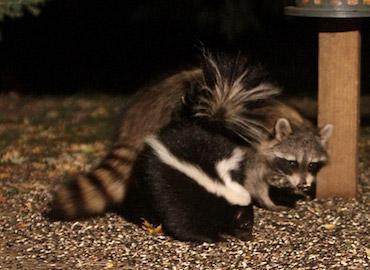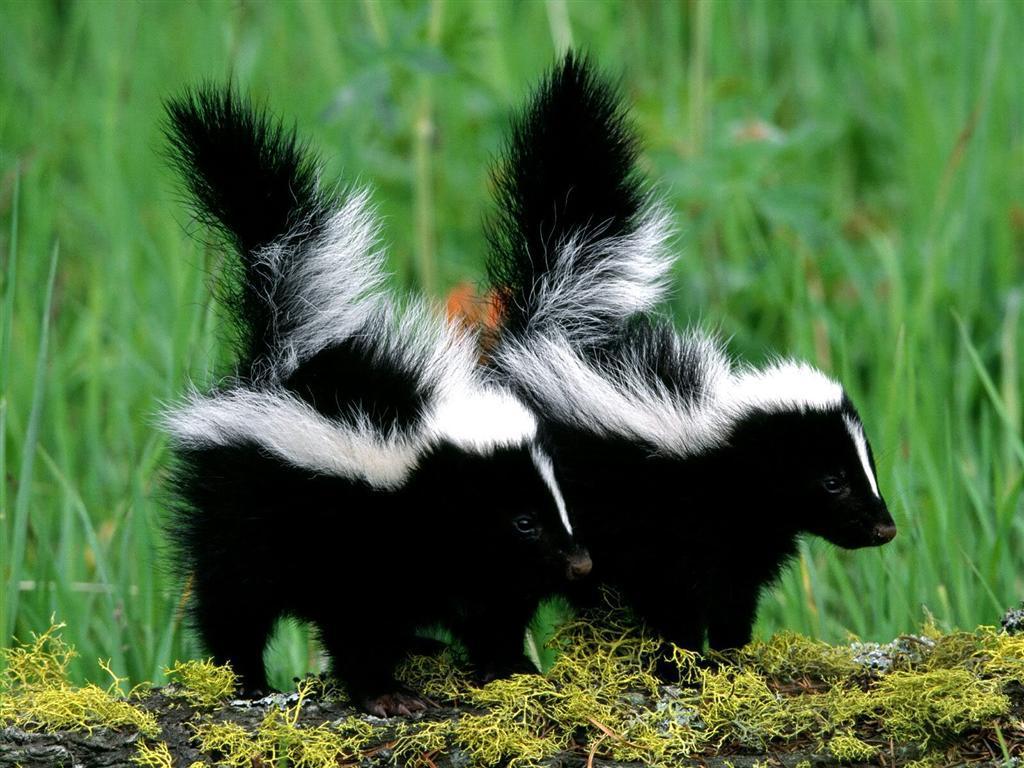The first image is the image on the left, the second image is the image on the right. Assess this claim about the two images: "There are two parallel skunks with a white vertical stripe on the front of their head.". Correct or not? Answer yes or no. Yes. The first image is the image on the left, the second image is the image on the right. Assess this claim about the two images: "In the left image, exactly one raccoon is standing alongside a skunk that is on all fours with its nose pointed down to a brown surface.". Correct or not? Answer yes or no. Yes. 